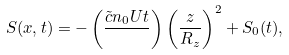Convert formula to latex. <formula><loc_0><loc_0><loc_500><loc_500>S ( { x } , t ) = - \left ( \frac { \tilde { c } n _ { 0 } U t } { } \right ) \left ( \frac { z } { R _ { z } } \right ) ^ { 2 } + S _ { 0 } ( t ) ,</formula> 